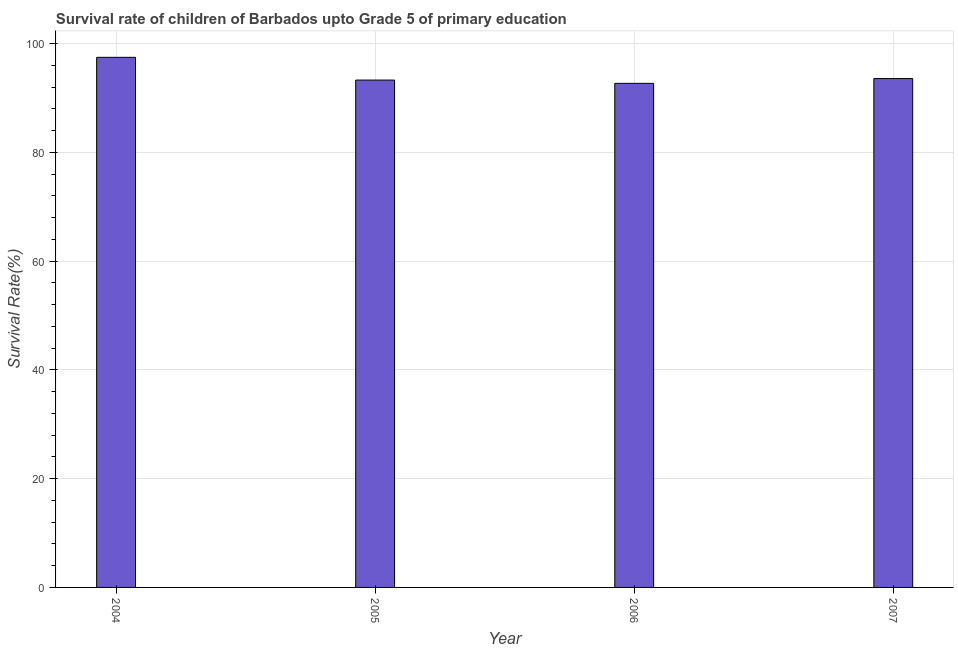Does the graph contain grids?
Keep it short and to the point. Yes. What is the title of the graph?
Your response must be concise. Survival rate of children of Barbados upto Grade 5 of primary education. What is the label or title of the X-axis?
Give a very brief answer. Year. What is the label or title of the Y-axis?
Keep it short and to the point. Survival Rate(%). What is the survival rate in 2005?
Offer a very short reply. 93.31. Across all years, what is the maximum survival rate?
Ensure brevity in your answer.  97.49. Across all years, what is the minimum survival rate?
Your answer should be compact. 92.71. In which year was the survival rate maximum?
Make the answer very short. 2004. In which year was the survival rate minimum?
Ensure brevity in your answer.  2006. What is the sum of the survival rate?
Provide a short and direct response. 377.09. What is the difference between the survival rate in 2004 and 2007?
Give a very brief answer. 3.91. What is the average survival rate per year?
Keep it short and to the point. 94.27. What is the median survival rate?
Offer a terse response. 93.45. What is the ratio of the survival rate in 2004 to that in 2005?
Your answer should be compact. 1.04. Is the difference between the survival rate in 2004 and 2005 greater than the difference between any two years?
Offer a very short reply. No. What is the difference between the highest and the second highest survival rate?
Make the answer very short. 3.91. What is the difference between the highest and the lowest survival rate?
Offer a terse response. 4.78. In how many years, is the survival rate greater than the average survival rate taken over all years?
Provide a succinct answer. 1. Are all the bars in the graph horizontal?
Provide a short and direct response. No. How many years are there in the graph?
Your answer should be compact. 4. Are the values on the major ticks of Y-axis written in scientific E-notation?
Provide a succinct answer. No. What is the Survival Rate(%) of 2004?
Offer a terse response. 97.49. What is the Survival Rate(%) in 2005?
Offer a terse response. 93.31. What is the Survival Rate(%) in 2006?
Provide a succinct answer. 92.71. What is the Survival Rate(%) in 2007?
Offer a terse response. 93.58. What is the difference between the Survival Rate(%) in 2004 and 2005?
Ensure brevity in your answer.  4.18. What is the difference between the Survival Rate(%) in 2004 and 2006?
Offer a terse response. 4.78. What is the difference between the Survival Rate(%) in 2004 and 2007?
Provide a short and direct response. 3.91. What is the difference between the Survival Rate(%) in 2005 and 2006?
Offer a terse response. 0.6. What is the difference between the Survival Rate(%) in 2005 and 2007?
Your answer should be compact. -0.28. What is the difference between the Survival Rate(%) in 2006 and 2007?
Your answer should be very brief. -0.88. What is the ratio of the Survival Rate(%) in 2004 to that in 2005?
Make the answer very short. 1.04. What is the ratio of the Survival Rate(%) in 2004 to that in 2006?
Make the answer very short. 1.05. What is the ratio of the Survival Rate(%) in 2004 to that in 2007?
Ensure brevity in your answer.  1.04. 